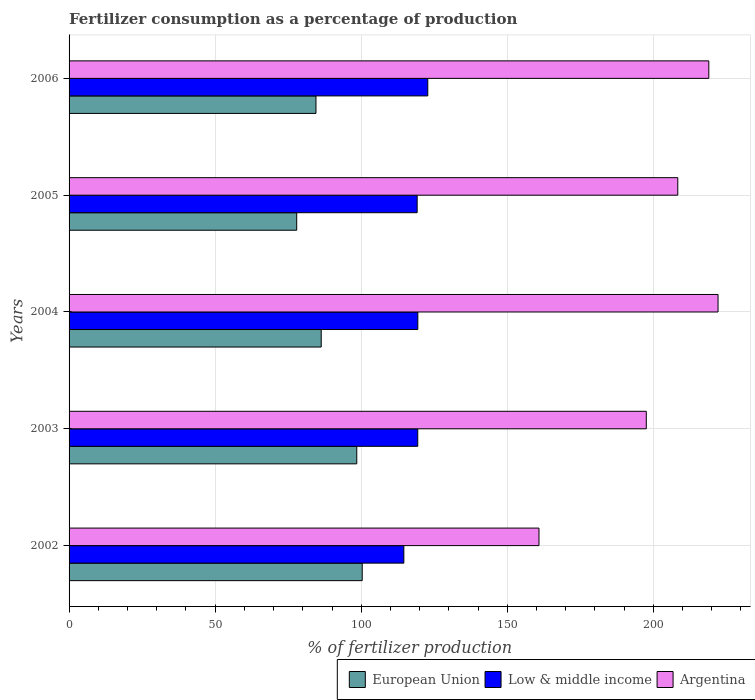How many groups of bars are there?
Keep it short and to the point. 5. Are the number of bars per tick equal to the number of legend labels?
Your response must be concise. Yes. Are the number of bars on each tick of the Y-axis equal?
Keep it short and to the point. Yes. How many bars are there on the 2nd tick from the bottom?
Your response must be concise. 3. What is the percentage of fertilizers consumed in European Union in 2004?
Offer a very short reply. 86.31. Across all years, what is the maximum percentage of fertilizers consumed in Argentina?
Your response must be concise. 222.14. Across all years, what is the minimum percentage of fertilizers consumed in European Union?
Give a very brief answer. 77.92. In which year was the percentage of fertilizers consumed in Argentina maximum?
Your answer should be very brief. 2004. What is the total percentage of fertilizers consumed in Low & middle income in the graph?
Keep it short and to the point. 595.27. What is the difference between the percentage of fertilizers consumed in Argentina in 2002 and that in 2005?
Provide a succinct answer. -47.51. What is the difference between the percentage of fertilizers consumed in European Union in 2004 and the percentage of fertilizers consumed in Argentina in 2006?
Offer a very short reply. -132.67. What is the average percentage of fertilizers consumed in Argentina per year?
Offer a very short reply. 201.59. In the year 2002, what is the difference between the percentage of fertilizers consumed in Low & middle income and percentage of fertilizers consumed in Argentina?
Ensure brevity in your answer.  -46.26. What is the ratio of the percentage of fertilizers consumed in Low & middle income in 2004 to that in 2005?
Give a very brief answer. 1. Is the difference between the percentage of fertilizers consumed in Low & middle income in 2003 and 2005 greater than the difference between the percentage of fertilizers consumed in Argentina in 2003 and 2005?
Your answer should be compact. Yes. What is the difference between the highest and the second highest percentage of fertilizers consumed in Low & middle income?
Provide a succinct answer. 3.41. What is the difference between the highest and the lowest percentage of fertilizers consumed in Argentina?
Make the answer very short. 61.29. In how many years, is the percentage of fertilizers consumed in European Union greater than the average percentage of fertilizers consumed in European Union taken over all years?
Your answer should be very brief. 2. Is the sum of the percentage of fertilizers consumed in European Union in 2002 and 2004 greater than the maximum percentage of fertilizers consumed in Argentina across all years?
Your answer should be very brief. No. What does the 2nd bar from the top in 2006 represents?
Make the answer very short. Low & middle income. How many years are there in the graph?
Give a very brief answer. 5. What is the difference between two consecutive major ticks on the X-axis?
Make the answer very short. 50. Are the values on the major ticks of X-axis written in scientific E-notation?
Your answer should be very brief. No. Does the graph contain any zero values?
Your response must be concise. No. Where does the legend appear in the graph?
Ensure brevity in your answer.  Bottom right. How many legend labels are there?
Your answer should be very brief. 3. What is the title of the graph?
Offer a very short reply. Fertilizer consumption as a percentage of production. What is the label or title of the X-axis?
Your answer should be compact. % of fertilizer production. What is the % of fertilizer production of European Union in 2002?
Your answer should be compact. 100.34. What is the % of fertilizer production of Low & middle income in 2002?
Offer a very short reply. 114.59. What is the % of fertilizer production of Argentina in 2002?
Your answer should be compact. 160.85. What is the % of fertilizer production in European Union in 2003?
Keep it short and to the point. 98.48. What is the % of fertilizer production in Low & middle income in 2003?
Ensure brevity in your answer.  119.36. What is the % of fertilizer production in Argentina in 2003?
Provide a succinct answer. 197.58. What is the % of fertilizer production of European Union in 2004?
Your answer should be compact. 86.31. What is the % of fertilizer production in Low & middle income in 2004?
Provide a short and direct response. 119.38. What is the % of fertilizer production of Argentina in 2004?
Offer a very short reply. 222.14. What is the % of fertilizer production in European Union in 2005?
Ensure brevity in your answer.  77.92. What is the % of fertilizer production in Low & middle income in 2005?
Give a very brief answer. 119.15. What is the % of fertilizer production in Argentina in 2005?
Keep it short and to the point. 208.36. What is the % of fertilizer production of European Union in 2006?
Offer a very short reply. 84.51. What is the % of fertilizer production of Low & middle income in 2006?
Your answer should be compact. 122.79. What is the % of fertilizer production of Argentina in 2006?
Ensure brevity in your answer.  218.98. Across all years, what is the maximum % of fertilizer production in European Union?
Offer a very short reply. 100.34. Across all years, what is the maximum % of fertilizer production in Low & middle income?
Your response must be concise. 122.79. Across all years, what is the maximum % of fertilizer production in Argentina?
Give a very brief answer. 222.14. Across all years, what is the minimum % of fertilizer production in European Union?
Keep it short and to the point. 77.92. Across all years, what is the minimum % of fertilizer production of Low & middle income?
Make the answer very short. 114.59. Across all years, what is the minimum % of fertilizer production of Argentina?
Provide a succinct answer. 160.85. What is the total % of fertilizer production in European Union in the graph?
Give a very brief answer. 447.56. What is the total % of fertilizer production of Low & middle income in the graph?
Your answer should be very brief. 595.27. What is the total % of fertilizer production in Argentina in the graph?
Provide a short and direct response. 1007.93. What is the difference between the % of fertilizer production of European Union in 2002 and that in 2003?
Give a very brief answer. 1.86. What is the difference between the % of fertilizer production of Low & middle income in 2002 and that in 2003?
Provide a short and direct response. -4.76. What is the difference between the % of fertilizer production of Argentina in 2002 and that in 2003?
Offer a terse response. -36.73. What is the difference between the % of fertilizer production of European Union in 2002 and that in 2004?
Keep it short and to the point. 14.03. What is the difference between the % of fertilizer production in Low & middle income in 2002 and that in 2004?
Your response must be concise. -4.79. What is the difference between the % of fertilizer production of Argentina in 2002 and that in 2004?
Give a very brief answer. -61.29. What is the difference between the % of fertilizer production of European Union in 2002 and that in 2005?
Offer a terse response. 22.42. What is the difference between the % of fertilizer production of Low & middle income in 2002 and that in 2005?
Ensure brevity in your answer.  -4.56. What is the difference between the % of fertilizer production in Argentina in 2002 and that in 2005?
Make the answer very short. -47.51. What is the difference between the % of fertilizer production of European Union in 2002 and that in 2006?
Offer a terse response. 15.83. What is the difference between the % of fertilizer production of Low & middle income in 2002 and that in 2006?
Give a very brief answer. -8.2. What is the difference between the % of fertilizer production of Argentina in 2002 and that in 2006?
Your answer should be very brief. -58.13. What is the difference between the % of fertilizer production in European Union in 2003 and that in 2004?
Give a very brief answer. 12.17. What is the difference between the % of fertilizer production of Low & middle income in 2003 and that in 2004?
Offer a very short reply. -0.02. What is the difference between the % of fertilizer production in Argentina in 2003 and that in 2004?
Offer a very short reply. -24.56. What is the difference between the % of fertilizer production in European Union in 2003 and that in 2005?
Your response must be concise. 20.56. What is the difference between the % of fertilizer production of Low & middle income in 2003 and that in 2005?
Provide a succinct answer. 0.2. What is the difference between the % of fertilizer production in Argentina in 2003 and that in 2005?
Provide a short and direct response. -10.78. What is the difference between the % of fertilizer production in European Union in 2003 and that in 2006?
Your answer should be very brief. 13.97. What is the difference between the % of fertilizer production in Low & middle income in 2003 and that in 2006?
Make the answer very short. -3.43. What is the difference between the % of fertilizer production of Argentina in 2003 and that in 2006?
Provide a short and direct response. -21.4. What is the difference between the % of fertilizer production of European Union in 2004 and that in 2005?
Your answer should be very brief. 8.39. What is the difference between the % of fertilizer production in Low & middle income in 2004 and that in 2005?
Make the answer very short. 0.23. What is the difference between the % of fertilizer production in Argentina in 2004 and that in 2005?
Your response must be concise. 13.78. What is the difference between the % of fertilizer production of European Union in 2004 and that in 2006?
Offer a very short reply. 1.8. What is the difference between the % of fertilizer production in Low & middle income in 2004 and that in 2006?
Offer a very short reply. -3.41. What is the difference between the % of fertilizer production of Argentina in 2004 and that in 2006?
Offer a very short reply. 3.16. What is the difference between the % of fertilizer production of European Union in 2005 and that in 2006?
Provide a succinct answer. -6.6. What is the difference between the % of fertilizer production of Low & middle income in 2005 and that in 2006?
Provide a short and direct response. -3.64. What is the difference between the % of fertilizer production in Argentina in 2005 and that in 2006?
Provide a short and direct response. -10.62. What is the difference between the % of fertilizer production in European Union in 2002 and the % of fertilizer production in Low & middle income in 2003?
Offer a very short reply. -19.01. What is the difference between the % of fertilizer production in European Union in 2002 and the % of fertilizer production in Argentina in 2003?
Your answer should be compact. -97.24. What is the difference between the % of fertilizer production of Low & middle income in 2002 and the % of fertilizer production of Argentina in 2003?
Offer a terse response. -82.99. What is the difference between the % of fertilizer production in European Union in 2002 and the % of fertilizer production in Low & middle income in 2004?
Offer a terse response. -19.04. What is the difference between the % of fertilizer production in European Union in 2002 and the % of fertilizer production in Argentina in 2004?
Offer a terse response. -121.8. What is the difference between the % of fertilizer production of Low & middle income in 2002 and the % of fertilizer production of Argentina in 2004?
Offer a terse response. -107.55. What is the difference between the % of fertilizer production in European Union in 2002 and the % of fertilizer production in Low & middle income in 2005?
Give a very brief answer. -18.81. What is the difference between the % of fertilizer production in European Union in 2002 and the % of fertilizer production in Argentina in 2005?
Your response must be concise. -108.02. What is the difference between the % of fertilizer production in Low & middle income in 2002 and the % of fertilizer production in Argentina in 2005?
Offer a terse response. -93.77. What is the difference between the % of fertilizer production in European Union in 2002 and the % of fertilizer production in Low & middle income in 2006?
Provide a succinct answer. -22.45. What is the difference between the % of fertilizer production of European Union in 2002 and the % of fertilizer production of Argentina in 2006?
Ensure brevity in your answer.  -118.64. What is the difference between the % of fertilizer production of Low & middle income in 2002 and the % of fertilizer production of Argentina in 2006?
Keep it short and to the point. -104.39. What is the difference between the % of fertilizer production of European Union in 2003 and the % of fertilizer production of Low & middle income in 2004?
Give a very brief answer. -20.9. What is the difference between the % of fertilizer production of European Union in 2003 and the % of fertilizer production of Argentina in 2004?
Offer a very short reply. -123.67. What is the difference between the % of fertilizer production of Low & middle income in 2003 and the % of fertilizer production of Argentina in 2004?
Offer a very short reply. -102.79. What is the difference between the % of fertilizer production in European Union in 2003 and the % of fertilizer production in Low & middle income in 2005?
Your answer should be very brief. -20.67. What is the difference between the % of fertilizer production in European Union in 2003 and the % of fertilizer production in Argentina in 2005?
Your answer should be compact. -109.88. What is the difference between the % of fertilizer production of Low & middle income in 2003 and the % of fertilizer production of Argentina in 2005?
Provide a succinct answer. -89.01. What is the difference between the % of fertilizer production of European Union in 2003 and the % of fertilizer production of Low & middle income in 2006?
Your answer should be very brief. -24.31. What is the difference between the % of fertilizer production of European Union in 2003 and the % of fertilizer production of Argentina in 2006?
Provide a succinct answer. -120.5. What is the difference between the % of fertilizer production in Low & middle income in 2003 and the % of fertilizer production in Argentina in 2006?
Ensure brevity in your answer.  -99.63. What is the difference between the % of fertilizer production in European Union in 2004 and the % of fertilizer production in Low & middle income in 2005?
Your response must be concise. -32.84. What is the difference between the % of fertilizer production of European Union in 2004 and the % of fertilizer production of Argentina in 2005?
Your response must be concise. -122.05. What is the difference between the % of fertilizer production in Low & middle income in 2004 and the % of fertilizer production in Argentina in 2005?
Provide a short and direct response. -88.98. What is the difference between the % of fertilizer production of European Union in 2004 and the % of fertilizer production of Low & middle income in 2006?
Your answer should be compact. -36.48. What is the difference between the % of fertilizer production of European Union in 2004 and the % of fertilizer production of Argentina in 2006?
Offer a very short reply. -132.67. What is the difference between the % of fertilizer production of Low & middle income in 2004 and the % of fertilizer production of Argentina in 2006?
Ensure brevity in your answer.  -99.6. What is the difference between the % of fertilizer production in European Union in 2005 and the % of fertilizer production in Low & middle income in 2006?
Your answer should be compact. -44.87. What is the difference between the % of fertilizer production of European Union in 2005 and the % of fertilizer production of Argentina in 2006?
Provide a short and direct response. -141.06. What is the difference between the % of fertilizer production of Low & middle income in 2005 and the % of fertilizer production of Argentina in 2006?
Offer a terse response. -99.83. What is the average % of fertilizer production in European Union per year?
Ensure brevity in your answer.  89.51. What is the average % of fertilizer production in Low & middle income per year?
Offer a terse response. 119.05. What is the average % of fertilizer production of Argentina per year?
Your response must be concise. 201.59. In the year 2002, what is the difference between the % of fertilizer production in European Union and % of fertilizer production in Low & middle income?
Your answer should be very brief. -14.25. In the year 2002, what is the difference between the % of fertilizer production of European Union and % of fertilizer production of Argentina?
Offer a terse response. -60.51. In the year 2002, what is the difference between the % of fertilizer production of Low & middle income and % of fertilizer production of Argentina?
Offer a terse response. -46.26. In the year 2003, what is the difference between the % of fertilizer production in European Union and % of fertilizer production in Low & middle income?
Your answer should be very brief. -20.88. In the year 2003, what is the difference between the % of fertilizer production of European Union and % of fertilizer production of Argentina?
Your answer should be compact. -99.11. In the year 2003, what is the difference between the % of fertilizer production in Low & middle income and % of fertilizer production in Argentina?
Make the answer very short. -78.23. In the year 2004, what is the difference between the % of fertilizer production in European Union and % of fertilizer production in Low & middle income?
Your answer should be compact. -33.07. In the year 2004, what is the difference between the % of fertilizer production of European Union and % of fertilizer production of Argentina?
Make the answer very short. -135.84. In the year 2004, what is the difference between the % of fertilizer production in Low & middle income and % of fertilizer production in Argentina?
Your response must be concise. -102.77. In the year 2005, what is the difference between the % of fertilizer production in European Union and % of fertilizer production in Low & middle income?
Your answer should be very brief. -41.23. In the year 2005, what is the difference between the % of fertilizer production in European Union and % of fertilizer production in Argentina?
Your answer should be very brief. -130.44. In the year 2005, what is the difference between the % of fertilizer production of Low & middle income and % of fertilizer production of Argentina?
Keep it short and to the point. -89.21. In the year 2006, what is the difference between the % of fertilizer production in European Union and % of fertilizer production in Low & middle income?
Provide a succinct answer. -38.27. In the year 2006, what is the difference between the % of fertilizer production in European Union and % of fertilizer production in Argentina?
Offer a terse response. -134.47. In the year 2006, what is the difference between the % of fertilizer production in Low & middle income and % of fertilizer production in Argentina?
Give a very brief answer. -96.19. What is the ratio of the % of fertilizer production of European Union in 2002 to that in 2003?
Keep it short and to the point. 1.02. What is the ratio of the % of fertilizer production of Low & middle income in 2002 to that in 2003?
Give a very brief answer. 0.96. What is the ratio of the % of fertilizer production of Argentina in 2002 to that in 2003?
Provide a succinct answer. 0.81. What is the ratio of the % of fertilizer production of European Union in 2002 to that in 2004?
Make the answer very short. 1.16. What is the ratio of the % of fertilizer production of Low & middle income in 2002 to that in 2004?
Your answer should be very brief. 0.96. What is the ratio of the % of fertilizer production of Argentina in 2002 to that in 2004?
Offer a very short reply. 0.72. What is the ratio of the % of fertilizer production in European Union in 2002 to that in 2005?
Provide a succinct answer. 1.29. What is the ratio of the % of fertilizer production of Low & middle income in 2002 to that in 2005?
Offer a terse response. 0.96. What is the ratio of the % of fertilizer production in Argentina in 2002 to that in 2005?
Provide a short and direct response. 0.77. What is the ratio of the % of fertilizer production in European Union in 2002 to that in 2006?
Keep it short and to the point. 1.19. What is the ratio of the % of fertilizer production in Argentina in 2002 to that in 2006?
Offer a terse response. 0.73. What is the ratio of the % of fertilizer production in European Union in 2003 to that in 2004?
Make the answer very short. 1.14. What is the ratio of the % of fertilizer production of Low & middle income in 2003 to that in 2004?
Provide a succinct answer. 1. What is the ratio of the % of fertilizer production of Argentina in 2003 to that in 2004?
Provide a succinct answer. 0.89. What is the ratio of the % of fertilizer production of European Union in 2003 to that in 2005?
Your response must be concise. 1.26. What is the ratio of the % of fertilizer production in Low & middle income in 2003 to that in 2005?
Ensure brevity in your answer.  1. What is the ratio of the % of fertilizer production in Argentina in 2003 to that in 2005?
Offer a terse response. 0.95. What is the ratio of the % of fertilizer production in European Union in 2003 to that in 2006?
Give a very brief answer. 1.17. What is the ratio of the % of fertilizer production of Argentina in 2003 to that in 2006?
Provide a succinct answer. 0.9. What is the ratio of the % of fertilizer production in European Union in 2004 to that in 2005?
Provide a succinct answer. 1.11. What is the ratio of the % of fertilizer production in Argentina in 2004 to that in 2005?
Your answer should be compact. 1.07. What is the ratio of the % of fertilizer production of European Union in 2004 to that in 2006?
Offer a terse response. 1.02. What is the ratio of the % of fertilizer production in Low & middle income in 2004 to that in 2006?
Provide a short and direct response. 0.97. What is the ratio of the % of fertilizer production of Argentina in 2004 to that in 2006?
Your answer should be compact. 1.01. What is the ratio of the % of fertilizer production in European Union in 2005 to that in 2006?
Your answer should be very brief. 0.92. What is the ratio of the % of fertilizer production of Low & middle income in 2005 to that in 2006?
Make the answer very short. 0.97. What is the ratio of the % of fertilizer production of Argentina in 2005 to that in 2006?
Your answer should be compact. 0.95. What is the difference between the highest and the second highest % of fertilizer production of European Union?
Offer a terse response. 1.86. What is the difference between the highest and the second highest % of fertilizer production of Low & middle income?
Your answer should be compact. 3.41. What is the difference between the highest and the second highest % of fertilizer production in Argentina?
Give a very brief answer. 3.16. What is the difference between the highest and the lowest % of fertilizer production of European Union?
Make the answer very short. 22.42. What is the difference between the highest and the lowest % of fertilizer production in Low & middle income?
Make the answer very short. 8.2. What is the difference between the highest and the lowest % of fertilizer production in Argentina?
Offer a very short reply. 61.29. 